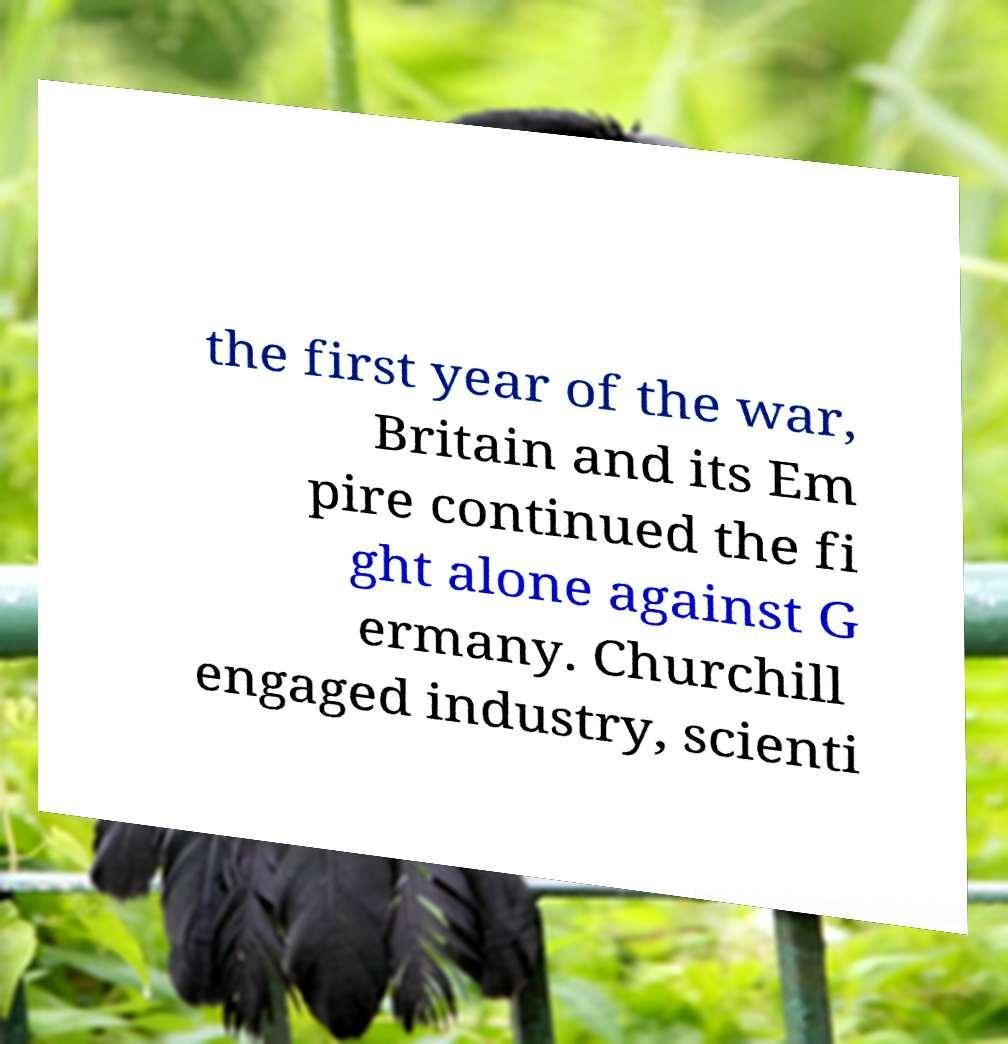Could you extract and type out the text from this image? the first year of the war, Britain and its Em pire continued the fi ght alone against G ermany. Churchill engaged industry, scienti 